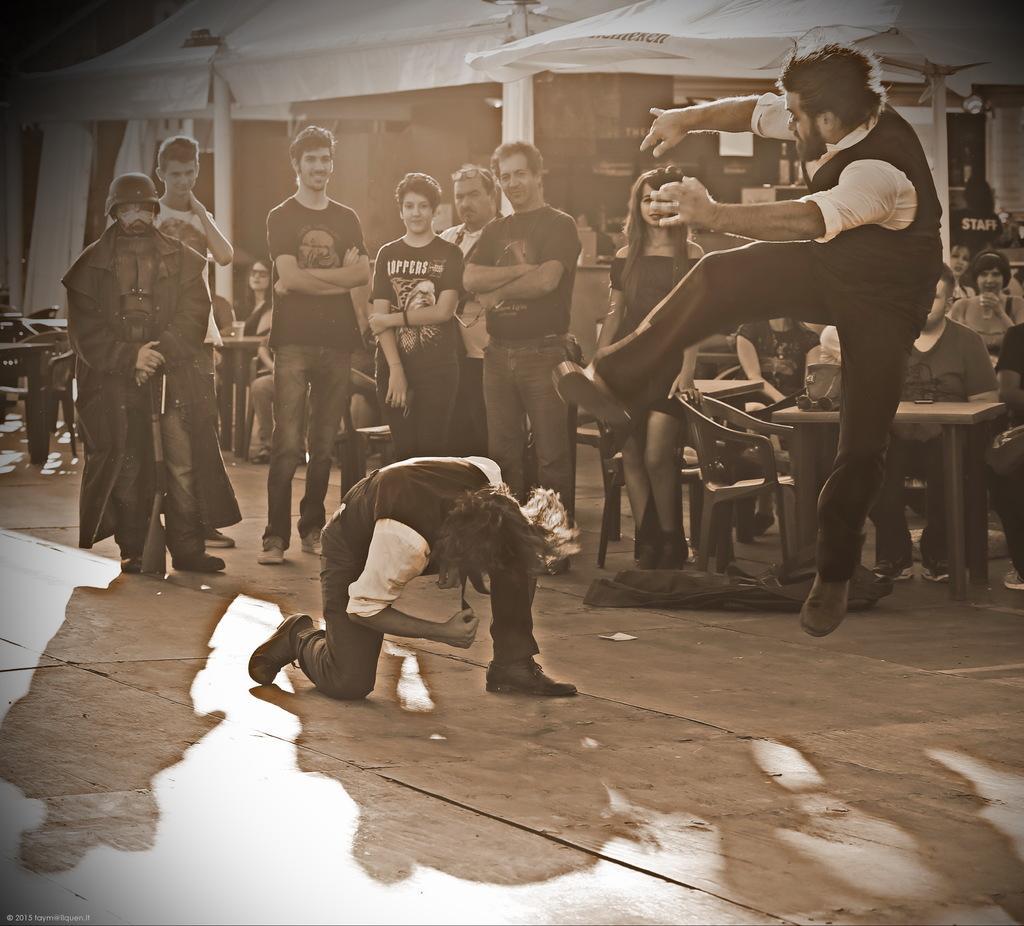Can you describe this image briefly? In this picture, we can see a few people sitting, and a few are standing, we can see the ground and some objects on the ground like bags, chairs, tables, poles, and sheds. 